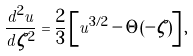Convert formula to latex. <formula><loc_0><loc_0><loc_500><loc_500>\frac { d ^ { 2 } u } { d \zeta ^ { 2 } } = \frac { 2 } { 3 } \left [ u ^ { 3 / 2 } - \Theta ( - \zeta ) \right ] ,</formula> 